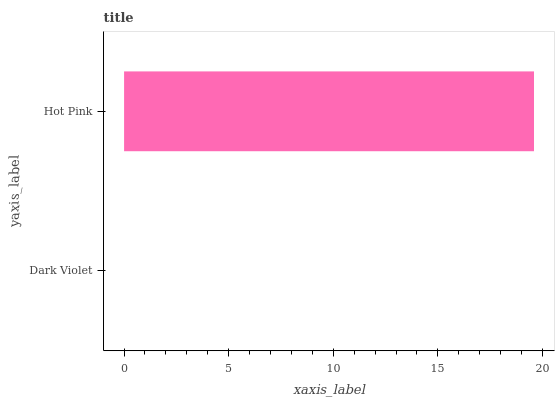Is Dark Violet the minimum?
Answer yes or no. Yes. Is Hot Pink the maximum?
Answer yes or no. Yes. Is Hot Pink the minimum?
Answer yes or no. No. Is Hot Pink greater than Dark Violet?
Answer yes or no. Yes. Is Dark Violet less than Hot Pink?
Answer yes or no. Yes. Is Dark Violet greater than Hot Pink?
Answer yes or no. No. Is Hot Pink less than Dark Violet?
Answer yes or no. No. Is Hot Pink the high median?
Answer yes or no. Yes. Is Dark Violet the low median?
Answer yes or no. Yes. Is Dark Violet the high median?
Answer yes or no. No. Is Hot Pink the low median?
Answer yes or no. No. 